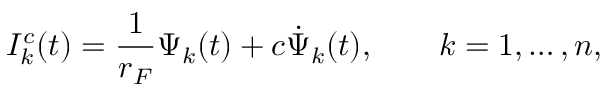<formula> <loc_0><loc_0><loc_500><loc_500>I _ { k } ^ { c } ( t ) = \frac { 1 } { r _ { F } } \Psi _ { k } ( t ) + c \dot { \Psi } _ { k } ( t ) , \quad k = 1 , \dots , n ,</formula> 